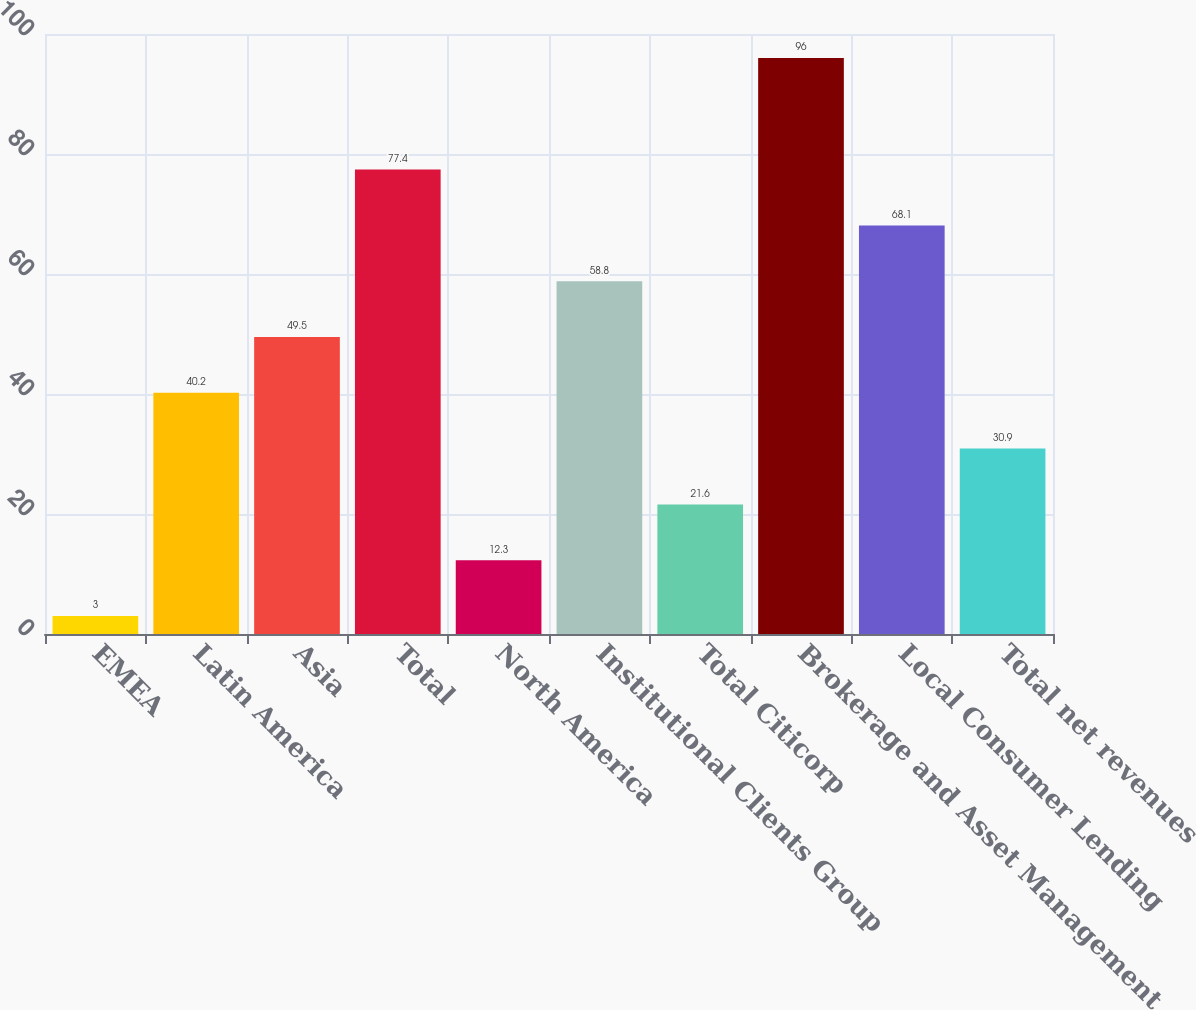Convert chart to OTSL. <chart><loc_0><loc_0><loc_500><loc_500><bar_chart><fcel>EMEA<fcel>Latin America<fcel>Asia<fcel>Total<fcel>North America<fcel>Institutional Clients Group<fcel>Total Citicorp<fcel>Brokerage and Asset Management<fcel>Local Consumer Lending<fcel>Total net revenues<nl><fcel>3<fcel>40.2<fcel>49.5<fcel>77.4<fcel>12.3<fcel>58.8<fcel>21.6<fcel>96<fcel>68.1<fcel>30.9<nl></chart> 